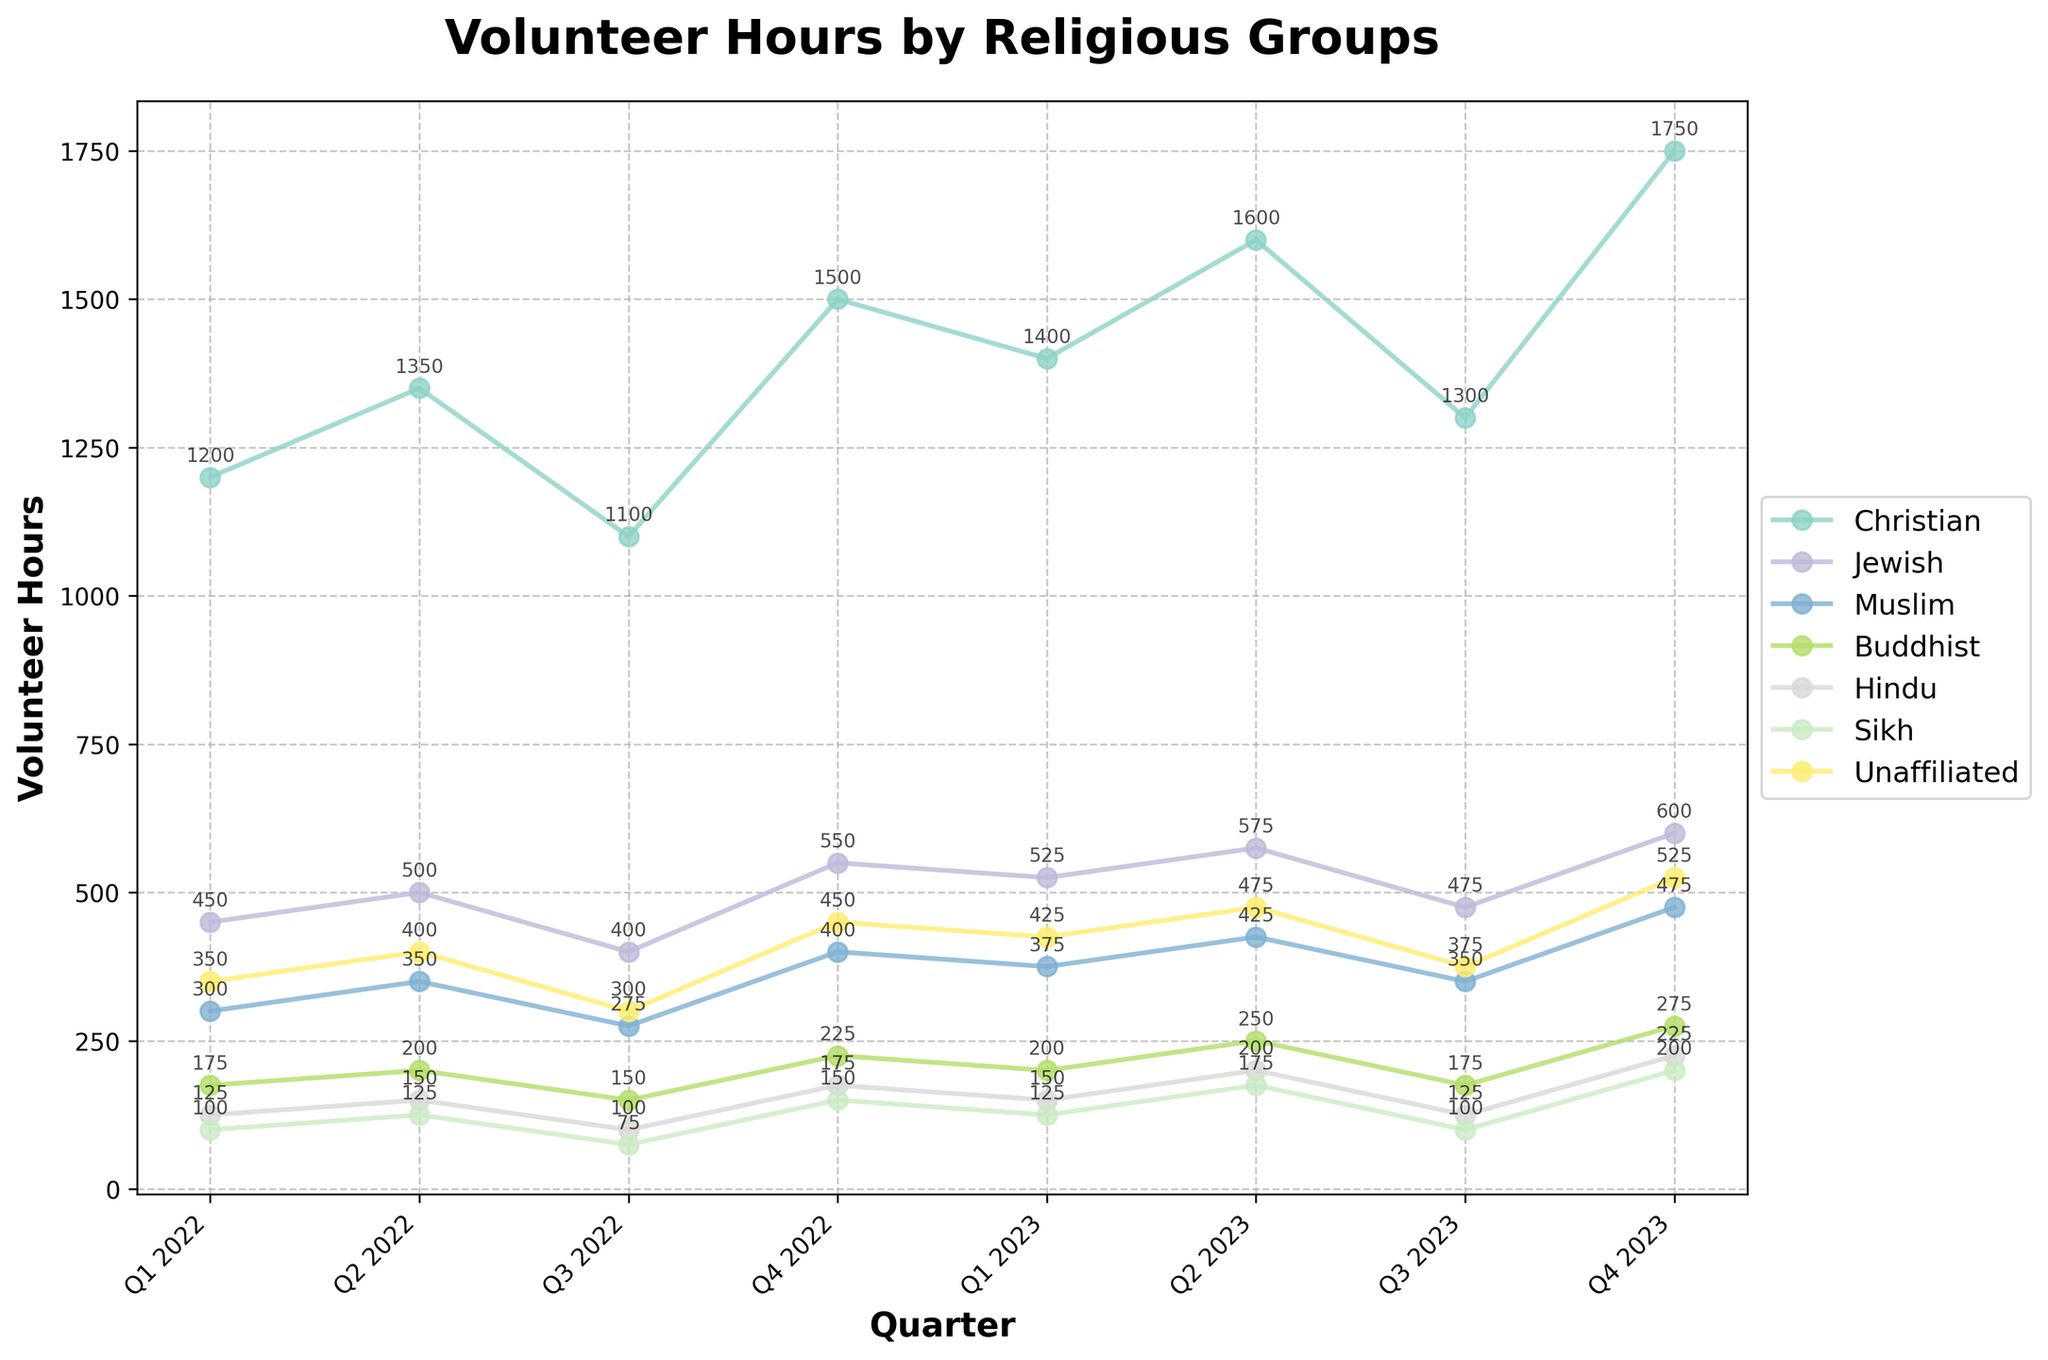What was the volunteer hour contribution by Christians in Q1 2023? For Q1 2023, look for the line corresponding to Christians and find their value on the y-axis. The plot shows 1400 volunteer hours.
Answer: 1400 Which religious group had the highest increase in volunteer hours from Q1 2022 to Q4 2023? Calculate the difference in volunteer hours between Q1 2022 and Q4 2023 for each group: Christians (1750-1200=550), Jewish (600-450=150), Muslims (475-300=175), Buddhists (275-175=100), Hindus (225-125=100), Sikhs (200-100=100), and Unaffiliated (525-350=175). Christians have the highest increase.
Answer: Christians Which religions showed a decline in volunteer hours between Q1 2023 and Q3 2023? Look for the values in Q1 2023 and Q3 2023: Christians (1400 to 1300), Jewish (525 to 475), Muslims (375 to 350), Buddhists (200 to 175), Hindus (150 to 125), Sikhs (125 to 100), Unaffiliated (425 to 375). All except Jewish and Muslims had a decline.
Answer: Christians, Buddhists, Hindus, Sikhs, Unaffiliated Between which quarters did the Jews contribute the highest increase in volunteer hours? Look at the Jewish contribution line and observe the maximum rise in volunteer hours between two consecutive quarters. The largest increase is between Q3 2022 (400) and Q4 2022 (550).
Answer: Q3 2022 to Q4 2022 Which group had the least fluctuation in volunteer hours over the period? Examine the lines and identify the one with the smallest changes in volunteer hours. The Buddhist group's line shows the smallest fluctuation, ranging between 150 and 275 hours.
Answer: Buddhists What is the sum of volunteer hours contributed by Muslims in the year 2022? Add the values for Muslims in each quarter of 2022: Q1 2022 (300) + Q2 2022 (350) + Q3 2022 (275) + Q4 2022 (400) = 300 + 350 + 275 + 400 = 1325.
Answer: 1325 Which quarter in 2023 saw the highest total volunteer hours contributed by all religious groups, and what was the total? For each quarter in 2023, sum the volunteer hours of all groups: 
Q1 2023: 1400 (Christians) + 525 (Jewish) + 375 (Muslims) + 200 (Buddhists) + 150 (Hindus) + 125 (Sikhs) + 425 (Unaffiliated) = 3200 
Q2 2023: 1600 + 575 + 425 + 250 + 200 + 175 + 475 = 3700 
Q3 2023: 1300 + 475 + 350 + 175 + 125 + 100 + 375 = 2900 
Q4 2023: 1750 + 600 + 475 + 275 + 225 + 200 + 525 = 4050 
Highest in Q4 2023 with 4050 hours.
Answer: Q4 2023, 4050 